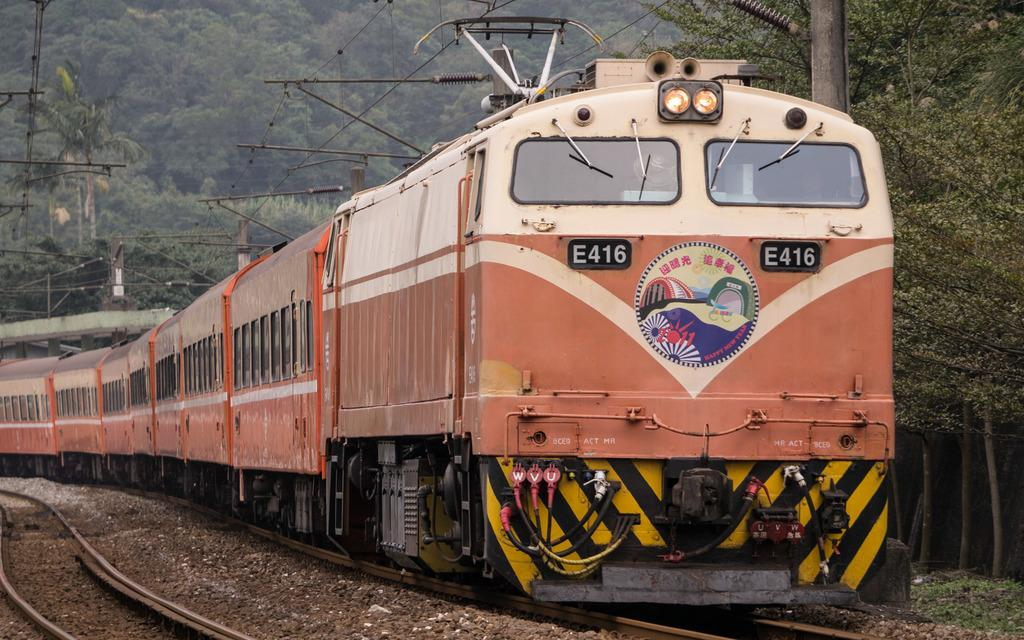<image>
Give a short and clear explanation of the subsequent image. A train is identified by the alphanumeric code E416. 